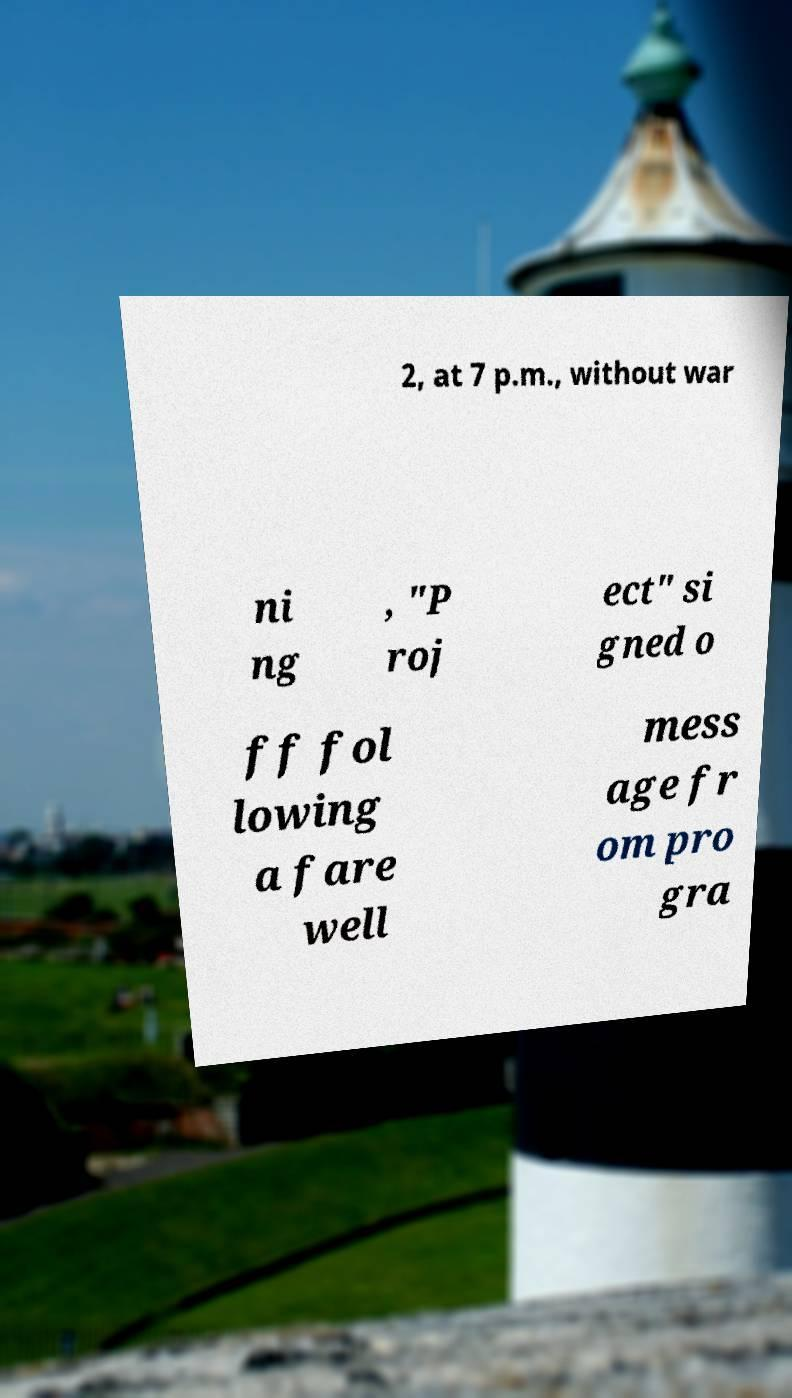Can you read and provide the text displayed in the image?This photo seems to have some interesting text. Can you extract and type it out for me? 2, at 7 p.m., without war ni ng , "P roj ect" si gned o ff fol lowing a fare well mess age fr om pro gra 